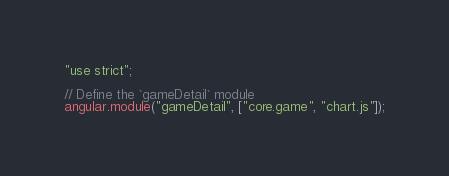<code> <loc_0><loc_0><loc_500><loc_500><_JavaScript_>"use strict";

// Define the `gameDetail` module
angular.module("gameDetail", ["core.game", "chart.js"]);
</code> 